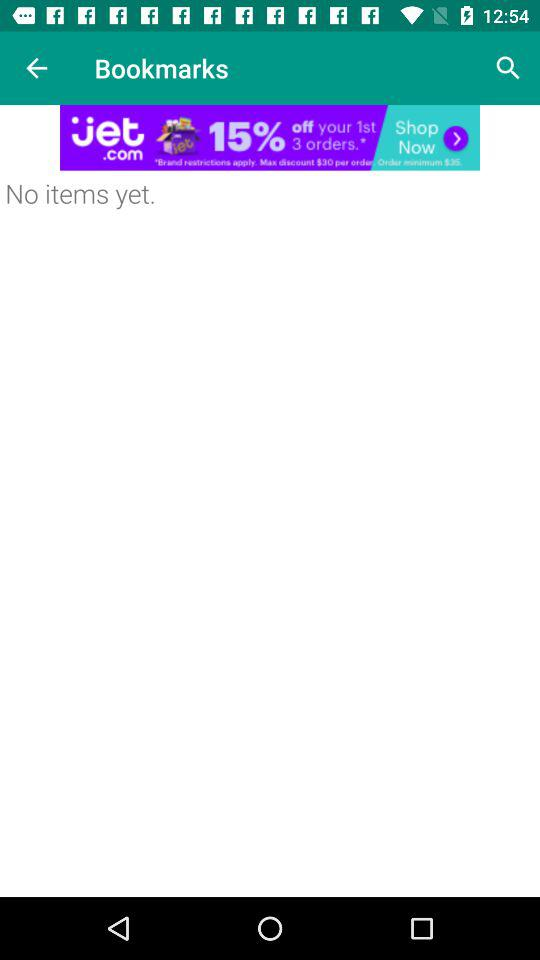How many items does the user have in their bookmarks?
Answer the question using a single word or phrase. 0 